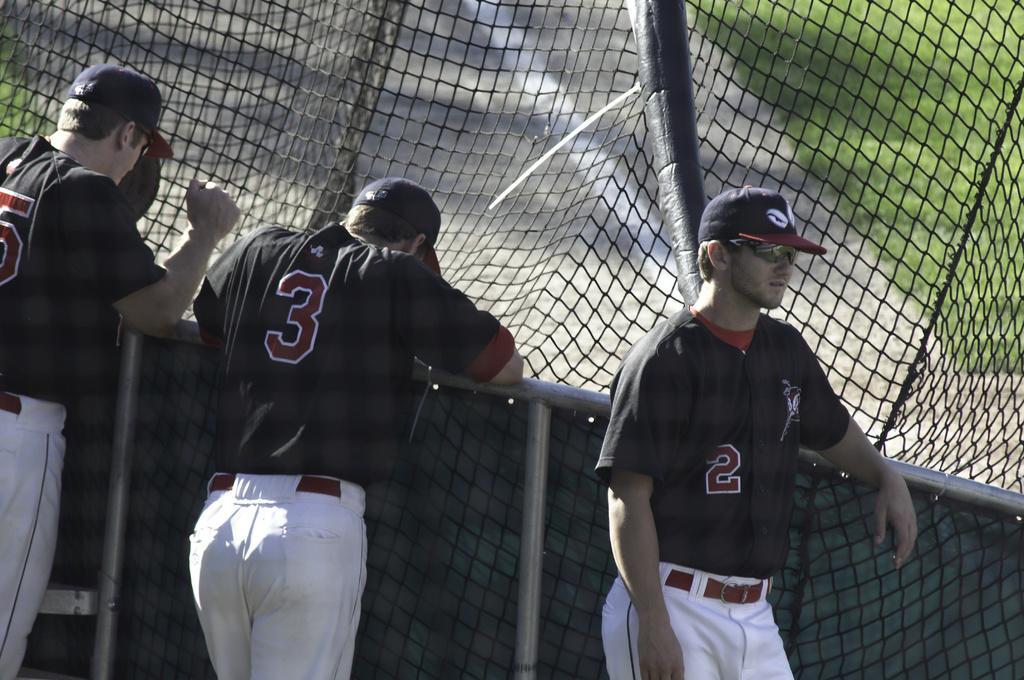Could you give a brief overview of what you see in this image? In the foreground of the image there are three persons standing. There are wearing black color t-shirts and white color pants. There are wearing caps. At the background of the image there is a fencing. There is a road and there is grass. 